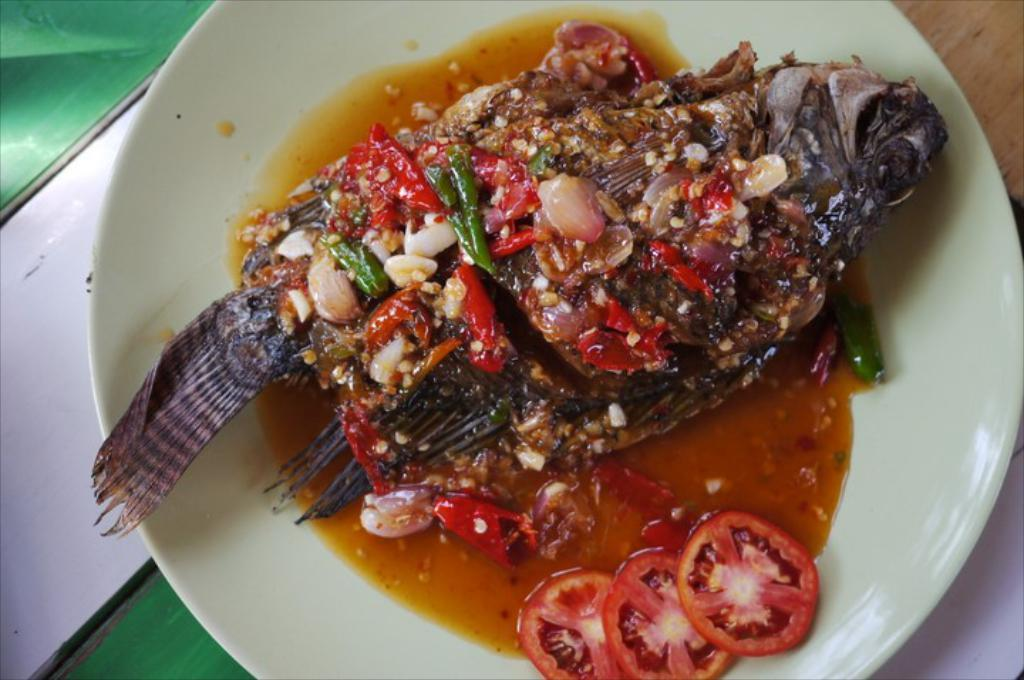What type of animal is present in the image? There is a fish in the image. What else can be seen in the image besides the fish? There are other eatables in the image. What color is the plate that holds the fish and other eatables? The plate is white in color. How much does the daughter weigh in the image? There is no daughter present in the image, so it is not possible to determine her weight. 